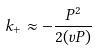Convert formula to latex. <formula><loc_0><loc_0><loc_500><loc_500>k _ { + } \approx - \frac { P ^ { 2 } } { 2 ( v P ) }</formula> 